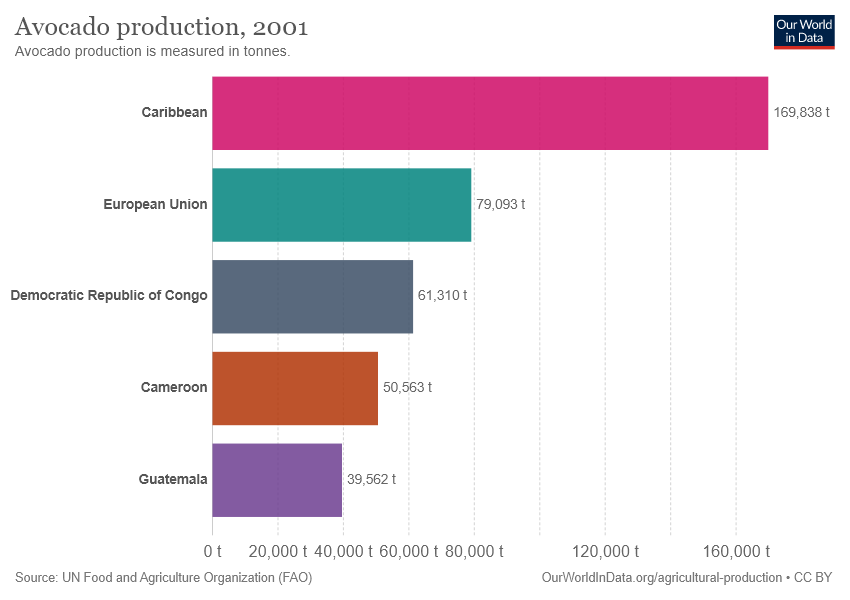Mention a couple of crucial points in this snapshot. The value of "caribbean" is 169838. What is the difference between the highest and smallest value among 130276...? 